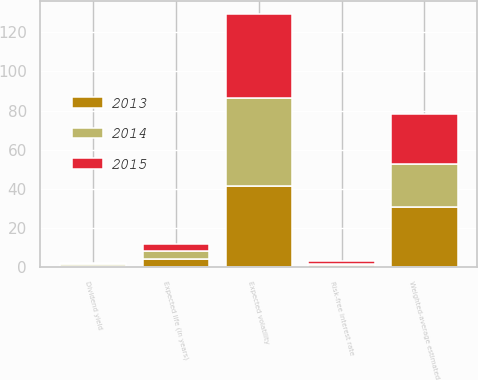Convert chart. <chart><loc_0><loc_0><loc_500><loc_500><stacked_bar_chart><ecel><fcel>Risk-free interest rate<fcel>Expected volatility<fcel>Expected life (in years)<fcel>Dividend yield<fcel>Weighted-average estimated<nl><fcel>2013<fcel>1.19<fcel>41.48<fcel>4.06<fcel>0.78<fcel>30.56<nl><fcel>2015<fcel>1.13<fcel>42.97<fcel>4.04<fcel>0.76<fcel>25.8<nl><fcel>2014<fcel>0.71<fcel>44.81<fcel>4.07<fcel>0.8<fcel>21.96<nl></chart> 